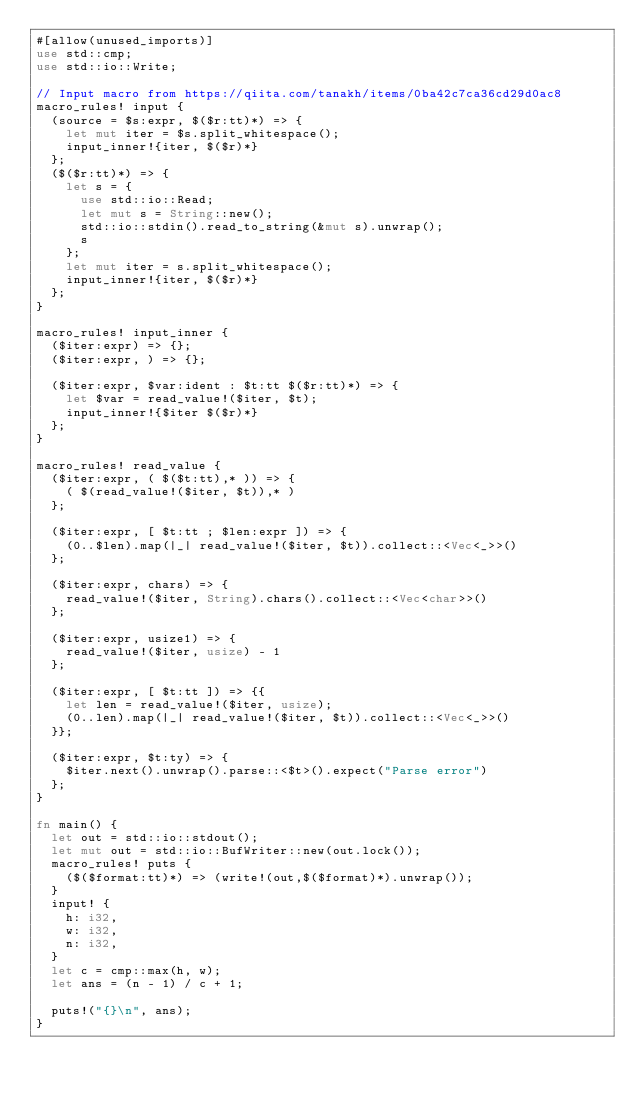Convert code to text. <code><loc_0><loc_0><loc_500><loc_500><_Rust_>#[allow(unused_imports)]
use std::cmp;
use std::io::Write;

// Input macro from https://qiita.com/tanakh/items/0ba42c7ca36cd29d0ac8
macro_rules! input {
  (source = $s:expr, $($r:tt)*) => {
    let mut iter = $s.split_whitespace();
    input_inner!{iter, $($r)*}
  };
  ($($r:tt)*) => {
    let s = {
      use std::io::Read;
      let mut s = String::new();
      std::io::stdin().read_to_string(&mut s).unwrap();
      s
    };
    let mut iter = s.split_whitespace();
    input_inner!{iter, $($r)*}
  };
}

macro_rules! input_inner {
  ($iter:expr) => {};
  ($iter:expr, ) => {};

  ($iter:expr, $var:ident : $t:tt $($r:tt)*) => {
    let $var = read_value!($iter, $t);
    input_inner!{$iter $($r)*}
  };
}

macro_rules! read_value {
  ($iter:expr, ( $($t:tt),* )) => {
    ( $(read_value!($iter, $t)),* )
  };

  ($iter:expr, [ $t:tt ; $len:expr ]) => {
    (0..$len).map(|_| read_value!($iter, $t)).collect::<Vec<_>>()
  };

  ($iter:expr, chars) => {
    read_value!($iter, String).chars().collect::<Vec<char>>()
  };

  ($iter:expr, usize1) => {
    read_value!($iter, usize) - 1
  };

  ($iter:expr, [ $t:tt ]) => {{
    let len = read_value!($iter, usize);
    (0..len).map(|_| read_value!($iter, $t)).collect::<Vec<_>>()
  }};

  ($iter:expr, $t:ty) => {
    $iter.next().unwrap().parse::<$t>().expect("Parse error")
  };
}

fn main() {
  let out = std::io::stdout();
  let mut out = std::io::BufWriter::new(out.lock());
  macro_rules! puts {
    ($($format:tt)*) => (write!(out,$($format)*).unwrap());
  }
  input! {
    h: i32,
    w: i32,
    n: i32,
  }
  let c = cmp::max(h, w);
  let ans = (n - 1) / c + 1;

  puts!("{}\n", ans);
}
</code> 